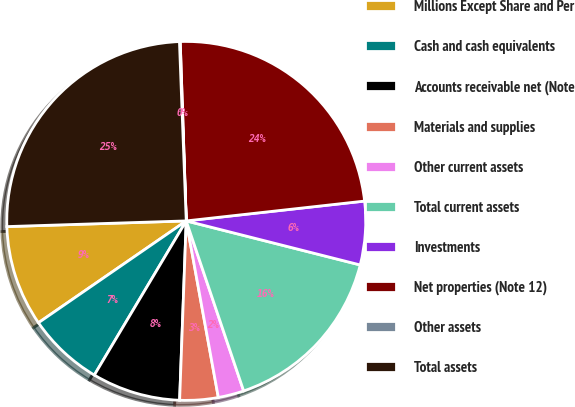<chart> <loc_0><loc_0><loc_500><loc_500><pie_chart><fcel>Millions Except Share and Per<fcel>Cash and cash equivalents<fcel>Accounts receivable net (Note<fcel>Materials and supplies<fcel>Other current assets<fcel>Total current assets<fcel>Investments<fcel>Net properties (Note 12)<fcel>Other assets<fcel>Total assets<nl><fcel>9.1%<fcel>6.84%<fcel>7.97%<fcel>3.45%<fcel>2.32%<fcel>15.87%<fcel>5.71%<fcel>23.77%<fcel>0.07%<fcel>24.9%<nl></chart> 